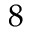Convert formula to latex. <formula><loc_0><loc_0><loc_500><loc_500>8</formula> 